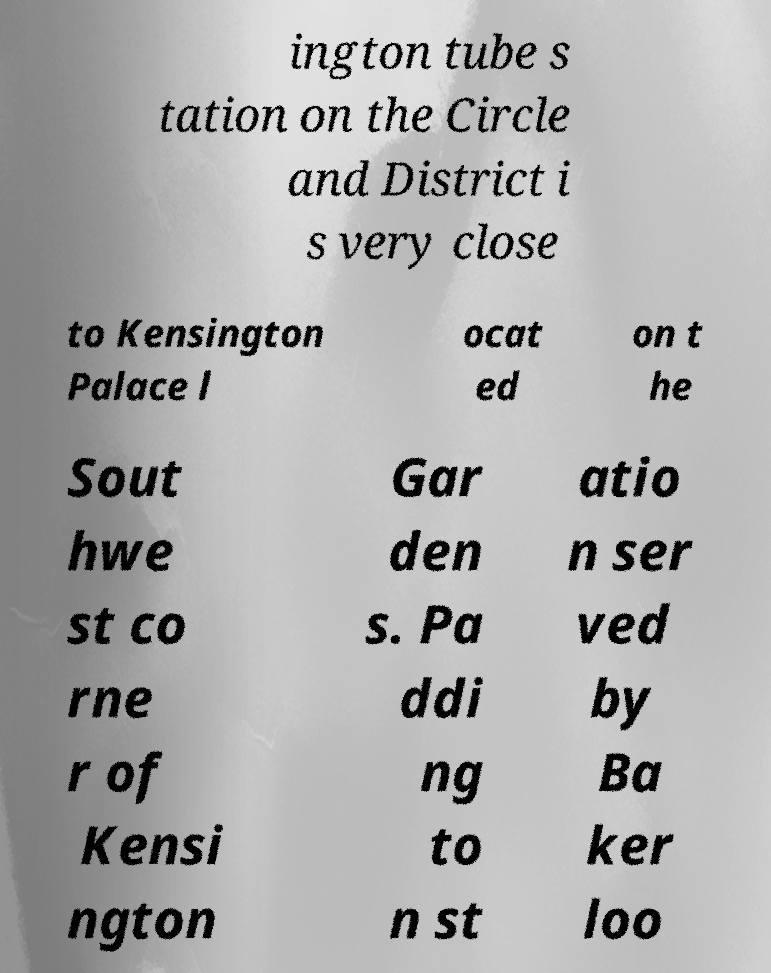There's text embedded in this image that I need extracted. Can you transcribe it verbatim? ington tube s tation on the Circle and District i s very close to Kensington Palace l ocat ed on t he Sout hwe st co rne r of Kensi ngton Gar den s. Pa ddi ng to n st atio n ser ved by Ba ker loo 